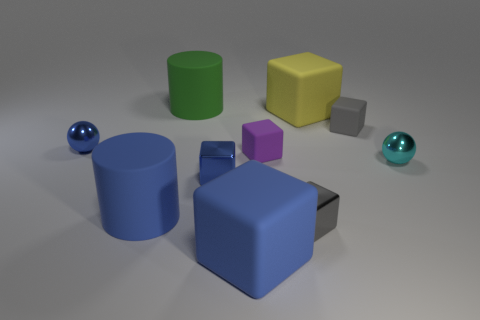Is the small ball that is on the right side of the small gray rubber object made of the same material as the big blue thing that is in front of the tiny gray metal cube?
Ensure brevity in your answer.  No. How many green rubber objects are behind the gray cube that is in front of the small cyan metal sphere?
Provide a succinct answer. 1. There is a blue matte object on the right side of the green rubber cylinder; does it have the same shape as the metal thing that is right of the tiny gray rubber thing?
Give a very brief answer. No. What size is the thing that is both behind the tiny gray matte thing and right of the purple object?
Provide a short and direct response. Large. The other big thing that is the same shape as the green object is what color?
Ensure brevity in your answer.  Blue. The large matte cylinder in front of the tiny ball to the right of the blue metallic cube is what color?
Give a very brief answer. Blue. What is the shape of the yellow object?
Provide a succinct answer. Cube. What is the shape of the object that is to the right of the big yellow rubber block and left of the tiny cyan thing?
Keep it short and to the point. Cube. What color is the other ball that is made of the same material as the blue ball?
Provide a succinct answer. Cyan. There is a gray thing in front of the tiny cube behind the metal object behind the tiny purple rubber thing; what shape is it?
Keep it short and to the point. Cube. 